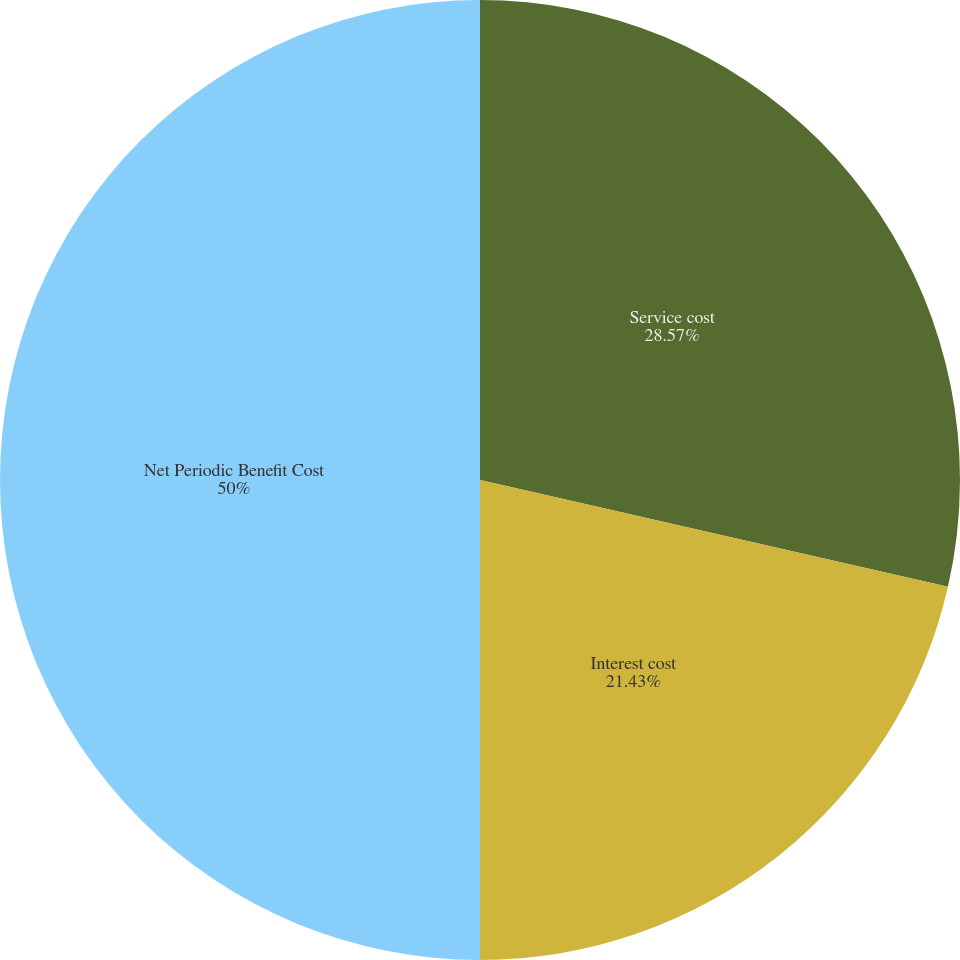<chart> <loc_0><loc_0><loc_500><loc_500><pie_chart><fcel>Service cost<fcel>Interest cost<fcel>Net Periodic Benefit Cost<nl><fcel>28.57%<fcel>21.43%<fcel>50.0%<nl></chart> 